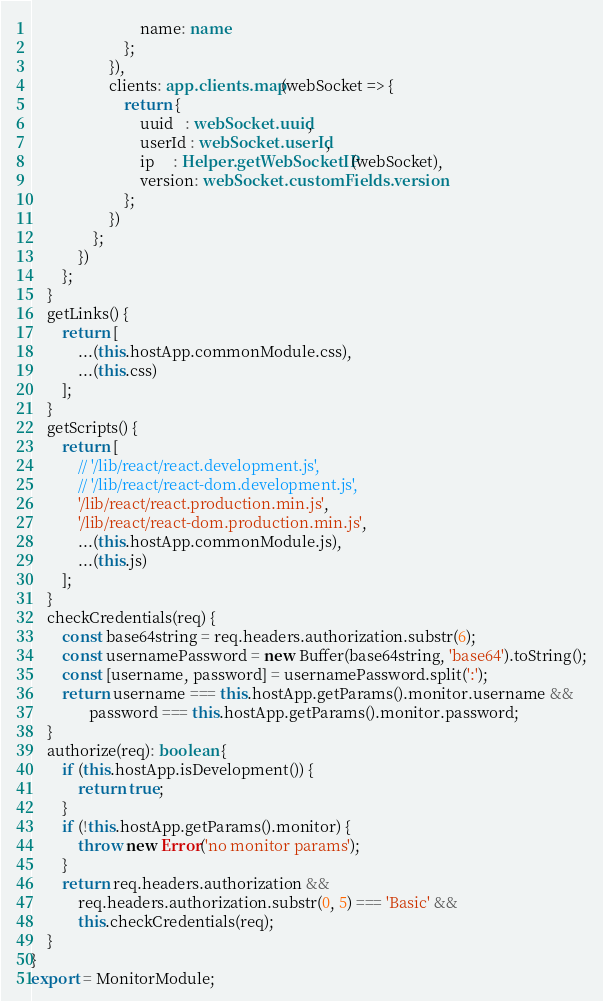<code> <loc_0><loc_0><loc_500><loc_500><_TypeScript_>                            name: name
                        };
                    }),
                    clients: app.clients.map(webSocket => {
                        return {
                            uuid   : webSocket.uuid,
                            userId : webSocket.userId,
                            ip     : Helper.getWebSocketIP(webSocket),
                            version: webSocket.customFields.version
                        };
                    })
                };
            })
        };
    }
    getLinks() {
        return [
            ...(this.hostApp.commonModule.css),
            ...(this.css)
        ];
    }
    getScripts() {
        return [
            // '/lib/react/react.development.js',
            // '/lib/react/react-dom.development.js',
            '/lib/react/react.production.min.js',
            '/lib/react/react-dom.production.min.js',
            ...(this.hostApp.commonModule.js),
            ...(this.js)
        ];
    }
    checkCredentials(req) {
        const base64string = req.headers.authorization.substr(6);
        const usernamePassword = new Buffer(base64string, 'base64').toString();
        const [username, password] = usernamePassword.split(':');
        return username === this.hostApp.getParams().monitor.username &&
               password === this.hostApp.getParams().monitor.password;
    }
    authorize(req): boolean {
        if (this.hostApp.isDevelopment()) {
            return true;
        }
        if (!this.hostApp.getParams().monitor) {
            throw new Error('no monitor params');
        }
        return req.headers.authorization &&
            req.headers.authorization.substr(0, 5) === 'Basic' &&
            this.checkCredentials(req);
    }
}
export = MonitorModule;
</code> 